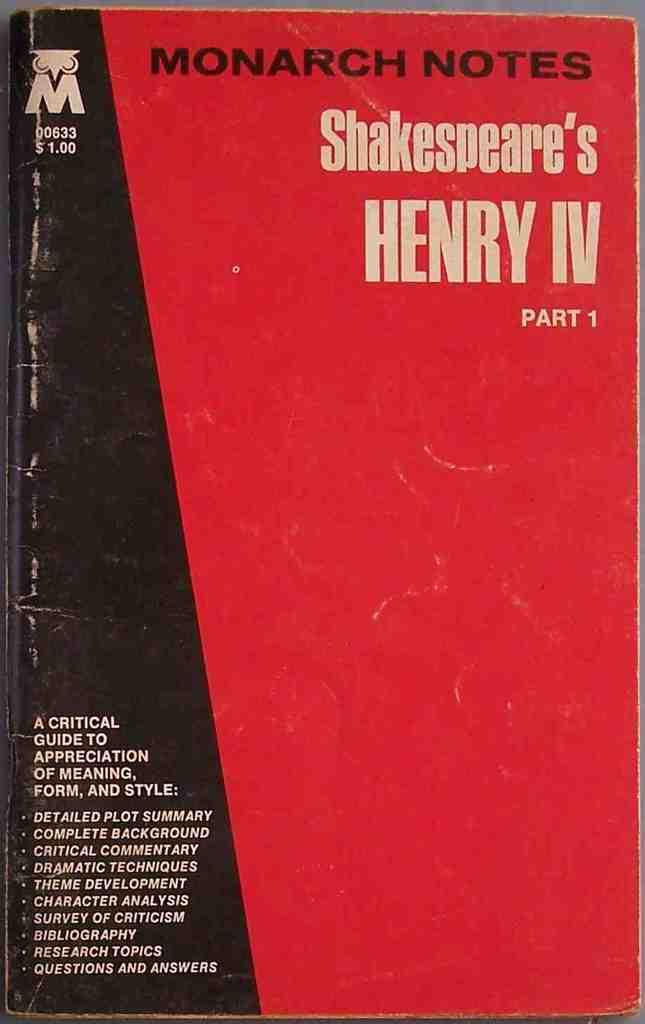<image>
Write a terse but informative summary of the picture. A textbook claims to be a guide to Shakespeare's Henry IV. 